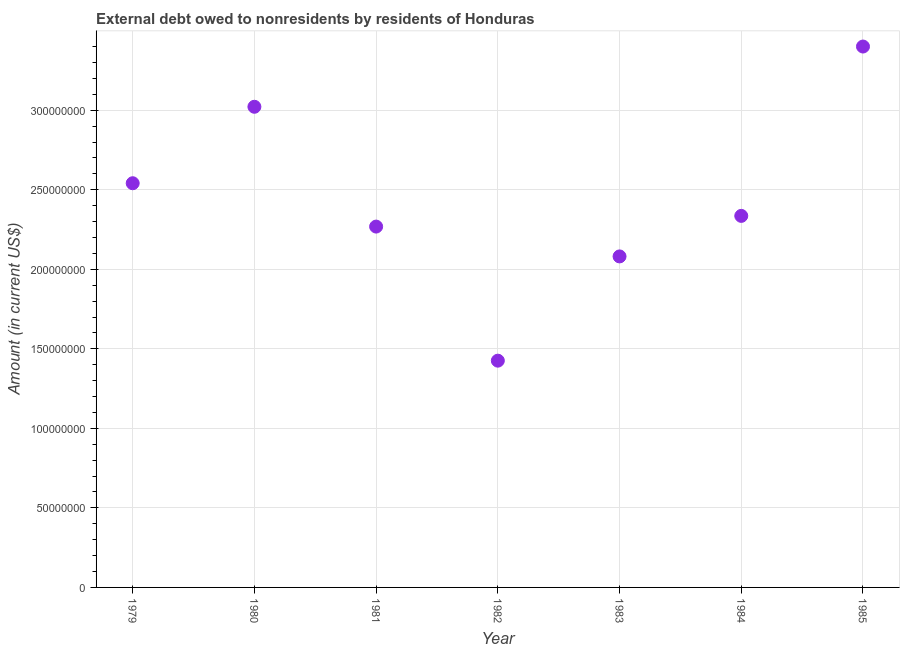What is the debt in 1984?
Keep it short and to the point. 2.34e+08. Across all years, what is the maximum debt?
Your answer should be compact. 3.40e+08. Across all years, what is the minimum debt?
Make the answer very short. 1.43e+08. In which year was the debt minimum?
Keep it short and to the point. 1982. What is the sum of the debt?
Your answer should be very brief. 1.71e+09. What is the difference between the debt in 1980 and 1985?
Offer a terse response. -3.79e+07. What is the average debt per year?
Ensure brevity in your answer.  2.44e+08. What is the median debt?
Offer a very short reply. 2.34e+08. In how many years, is the debt greater than 180000000 US$?
Offer a terse response. 6. What is the ratio of the debt in 1980 to that in 1984?
Your answer should be very brief. 1.29. What is the difference between the highest and the second highest debt?
Your response must be concise. 3.79e+07. What is the difference between the highest and the lowest debt?
Offer a very short reply. 1.97e+08. In how many years, is the debt greater than the average debt taken over all years?
Provide a succinct answer. 3. What is the difference between two consecutive major ticks on the Y-axis?
Offer a terse response. 5.00e+07. Does the graph contain grids?
Your answer should be compact. Yes. What is the title of the graph?
Your answer should be very brief. External debt owed to nonresidents by residents of Honduras. What is the label or title of the X-axis?
Your response must be concise. Year. What is the Amount (in current US$) in 1979?
Offer a terse response. 2.54e+08. What is the Amount (in current US$) in 1980?
Your answer should be very brief. 3.02e+08. What is the Amount (in current US$) in 1981?
Make the answer very short. 2.27e+08. What is the Amount (in current US$) in 1982?
Keep it short and to the point. 1.43e+08. What is the Amount (in current US$) in 1983?
Your answer should be compact. 2.08e+08. What is the Amount (in current US$) in 1984?
Ensure brevity in your answer.  2.34e+08. What is the Amount (in current US$) in 1985?
Your answer should be very brief. 3.40e+08. What is the difference between the Amount (in current US$) in 1979 and 1980?
Your response must be concise. -4.81e+07. What is the difference between the Amount (in current US$) in 1979 and 1981?
Provide a short and direct response. 2.73e+07. What is the difference between the Amount (in current US$) in 1979 and 1982?
Your response must be concise. 1.12e+08. What is the difference between the Amount (in current US$) in 1979 and 1983?
Your answer should be very brief. 4.60e+07. What is the difference between the Amount (in current US$) in 1979 and 1984?
Your answer should be compact. 2.05e+07. What is the difference between the Amount (in current US$) in 1979 and 1985?
Your answer should be compact. -8.59e+07. What is the difference between the Amount (in current US$) in 1980 and 1981?
Ensure brevity in your answer.  7.53e+07. What is the difference between the Amount (in current US$) in 1980 and 1982?
Offer a very short reply. 1.60e+08. What is the difference between the Amount (in current US$) in 1980 and 1983?
Your response must be concise. 9.41e+07. What is the difference between the Amount (in current US$) in 1980 and 1984?
Keep it short and to the point. 6.86e+07. What is the difference between the Amount (in current US$) in 1980 and 1985?
Your answer should be very brief. -3.79e+07. What is the difference between the Amount (in current US$) in 1981 and 1982?
Provide a short and direct response. 8.43e+07. What is the difference between the Amount (in current US$) in 1981 and 1983?
Your answer should be very brief. 1.88e+07. What is the difference between the Amount (in current US$) in 1981 and 1984?
Give a very brief answer. -6.73e+06. What is the difference between the Amount (in current US$) in 1981 and 1985?
Make the answer very short. -1.13e+08. What is the difference between the Amount (in current US$) in 1982 and 1983?
Offer a terse response. -6.55e+07. What is the difference between the Amount (in current US$) in 1982 and 1984?
Offer a terse response. -9.10e+07. What is the difference between the Amount (in current US$) in 1982 and 1985?
Your response must be concise. -1.97e+08. What is the difference between the Amount (in current US$) in 1983 and 1984?
Provide a short and direct response. -2.55e+07. What is the difference between the Amount (in current US$) in 1983 and 1985?
Ensure brevity in your answer.  -1.32e+08. What is the difference between the Amount (in current US$) in 1984 and 1985?
Give a very brief answer. -1.06e+08. What is the ratio of the Amount (in current US$) in 1979 to that in 1980?
Make the answer very short. 0.84. What is the ratio of the Amount (in current US$) in 1979 to that in 1981?
Provide a succinct answer. 1.12. What is the ratio of the Amount (in current US$) in 1979 to that in 1982?
Give a very brief answer. 1.78. What is the ratio of the Amount (in current US$) in 1979 to that in 1983?
Ensure brevity in your answer.  1.22. What is the ratio of the Amount (in current US$) in 1979 to that in 1984?
Provide a succinct answer. 1.09. What is the ratio of the Amount (in current US$) in 1979 to that in 1985?
Give a very brief answer. 0.75. What is the ratio of the Amount (in current US$) in 1980 to that in 1981?
Keep it short and to the point. 1.33. What is the ratio of the Amount (in current US$) in 1980 to that in 1982?
Your response must be concise. 2.12. What is the ratio of the Amount (in current US$) in 1980 to that in 1983?
Give a very brief answer. 1.45. What is the ratio of the Amount (in current US$) in 1980 to that in 1984?
Offer a terse response. 1.29. What is the ratio of the Amount (in current US$) in 1980 to that in 1985?
Provide a succinct answer. 0.89. What is the ratio of the Amount (in current US$) in 1981 to that in 1982?
Provide a succinct answer. 1.59. What is the ratio of the Amount (in current US$) in 1981 to that in 1983?
Offer a terse response. 1.09. What is the ratio of the Amount (in current US$) in 1981 to that in 1984?
Provide a succinct answer. 0.97. What is the ratio of the Amount (in current US$) in 1981 to that in 1985?
Provide a succinct answer. 0.67. What is the ratio of the Amount (in current US$) in 1982 to that in 1983?
Provide a short and direct response. 0.69. What is the ratio of the Amount (in current US$) in 1982 to that in 1984?
Make the answer very short. 0.61. What is the ratio of the Amount (in current US$) in 1982 to that in 1985?
Provide a short and direct response. 0.42. What is the ratio of the Amount (in current US$) in 1983 to that in 1984?
Offer a very short reply. 0.89. What is the ratio of the Amount (in current US$) in 1983 to that in 1985?
Your answer should be compact. 0.61. What is the ratio of the Amount (in current US$) in 1984 to that in 1985?
Keep it short and to the point. 0.69. 